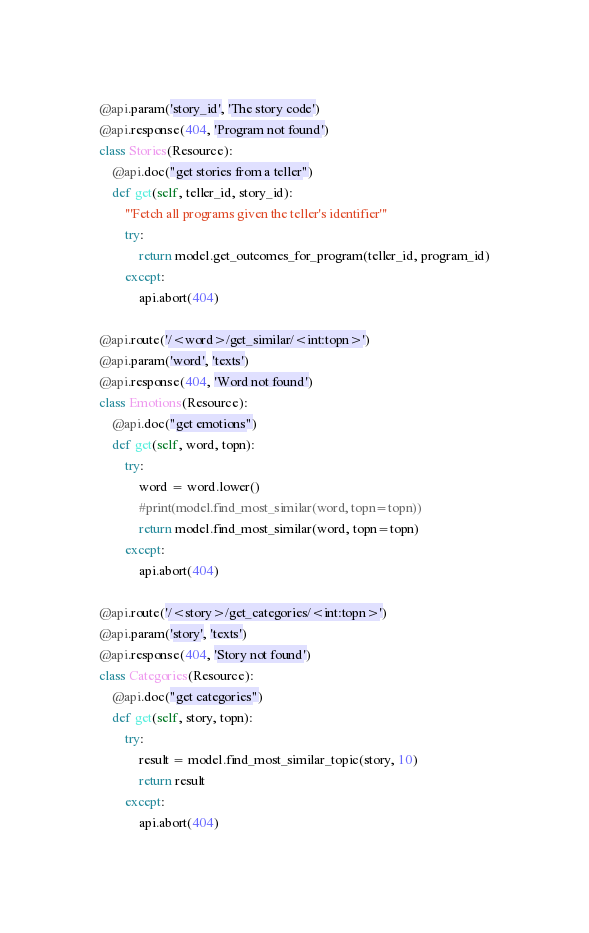<code> <loc_0><loc_0><loc_500><loc_500><_Python_>@api.param('story_id', 'The story code')
@api.response(404, 'Program not found')
class Stories(Resource):
    @api.doc("get stories from a teller")
    def get(self, teller_id, story_id):
        '''Fetch all programs given the teller's identifier'''
        try:
            return model.get_outcomes_for_program(teller_id, program_id)
        except:
            api.abort(404)

@api.route('/<word>/get_similar/<int:topn>')
@api.param('word', 'texts')
@api.response(404, 'Word not found')
class Emotions(Resource):
    @api.doc("get emotions")
    def get(self, word, topn):
        try:
            word = word.lower()
            #print(model.find_most_similar(word, topn=topn))
            return model.find_most_similar(word, topn=topn)
        except:
            api.abort(404)

@api.route('/<story>/get_categories/<int:topn>')
@api.param('story', 'texts')
@api.response(404, 'Story not found')
class Categories(Resource):
    @api.doc("get categories")
    def get(self, story, topn):
        try:
            result = model.find_most_similar_topic(story, 10)
            return result
        except:
            api.abort(404)
</code> 